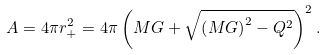<formula> <loc_0><loc_0><loc_500><loc_500>A = 4 \pi r _ { + } ^ { 2 } = 4 \pi \left ( M G + \sqrt { \left ( M G \right ) ^ { 2 } - Q ^ { 2 } } \right ) ^ { 2 } .</formula> 